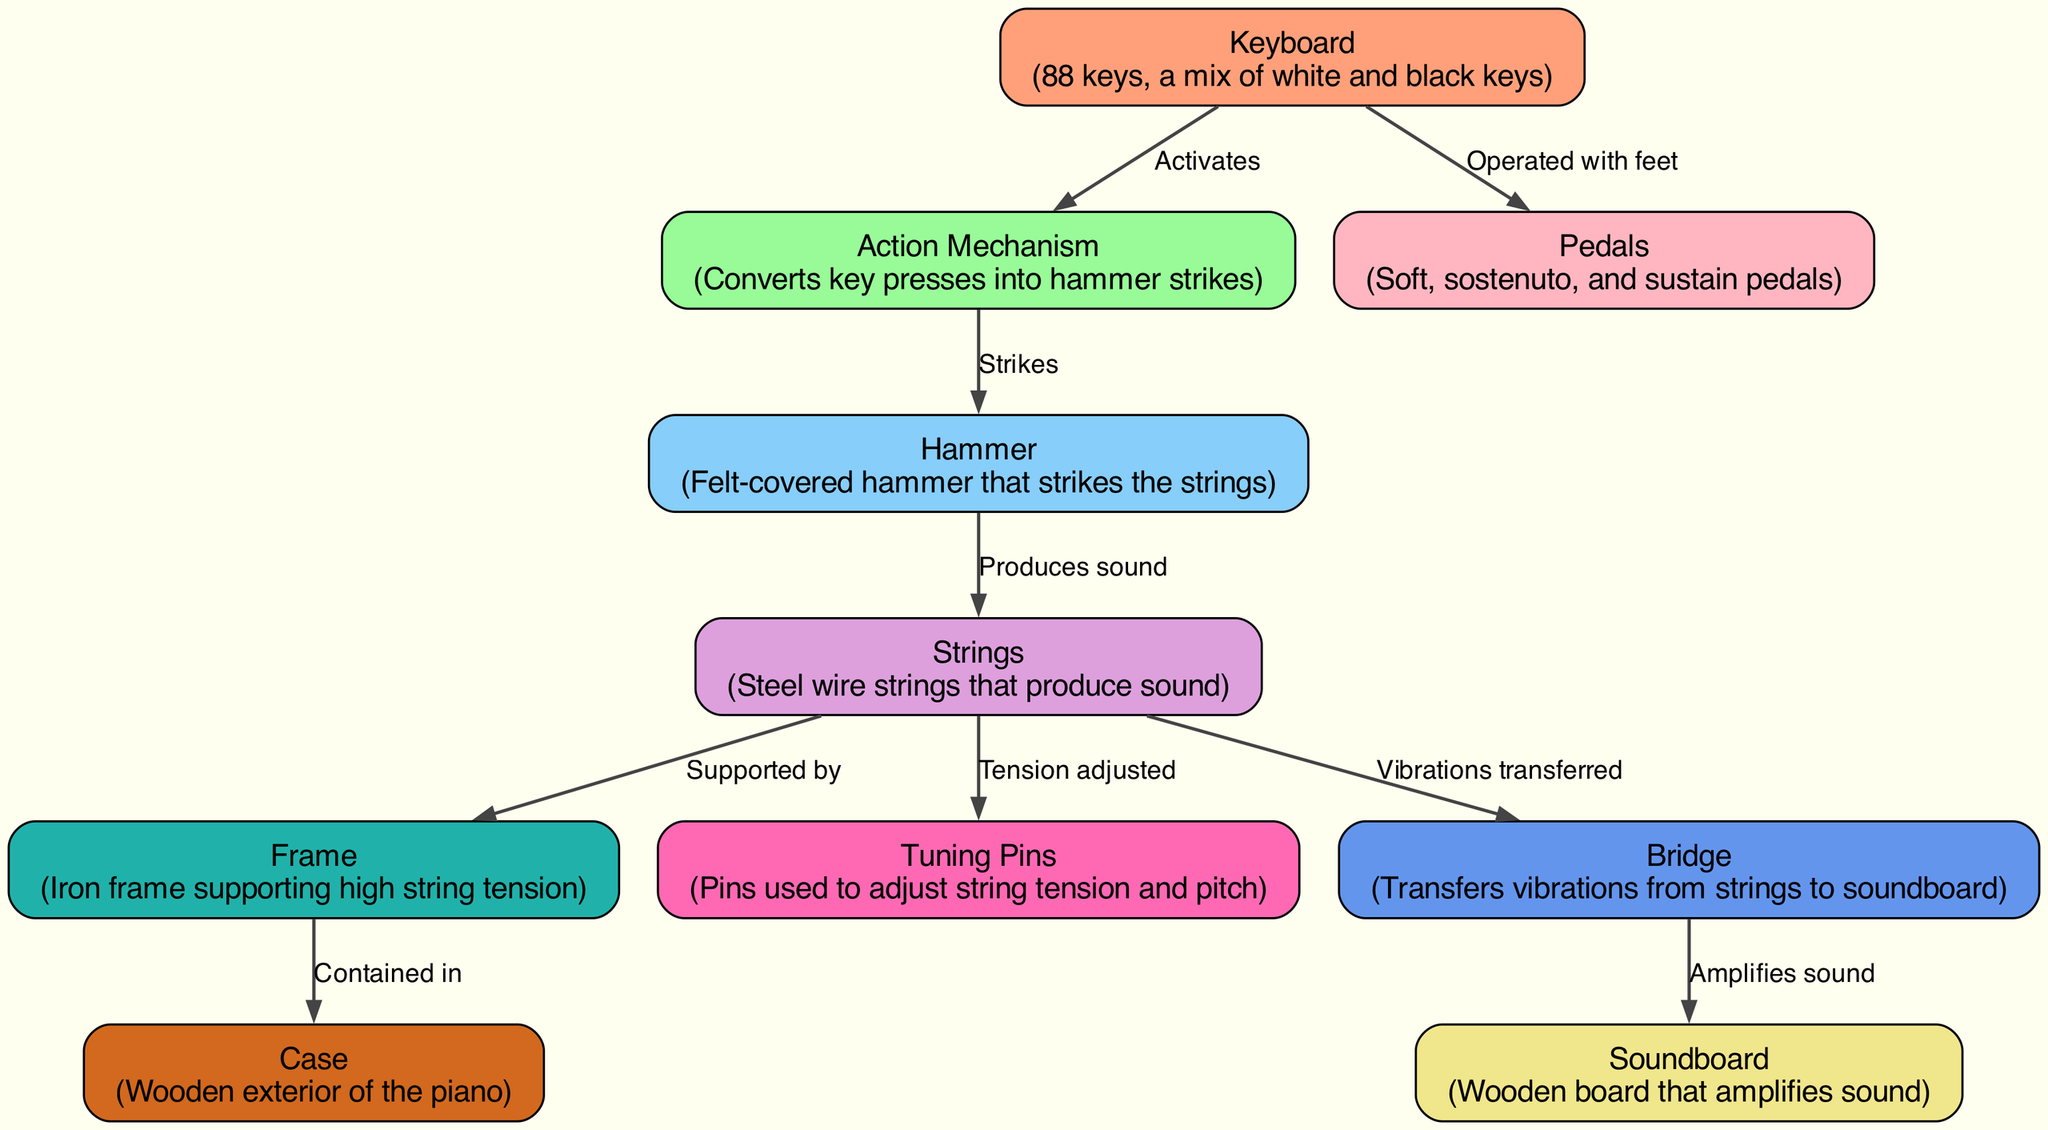What is the total number of nodes in the diagram? The diagram displays the parts of a grand piano represented as nodes. By counting the individual nodes listed, we find that there are 10 nodes in total.
Answer: 10 What does the Action Mechanism convert? The Action Mechanism node is connected to the Keyboard and is labeled "Converts key presses into hammer strikes." Thus, it converts key presses.
Answer: key presses Which component strikes the strings? The edge labeled "Strikes" connects the Action Mechanism to the Hammer, indicating that the Hammer is the component that strikes the strings.
Answer: Hammer How many types of pedals are shown in the diagram? The Pedals node describes three types: soft, sostenuto, and sustain pedals. This can be directly obtained by reading the description under the Pedals node.
Answer: three What is the relationship between Strings and Tuning Pins? The arrow from the Strings to the Tuning Pins indicates that Tuning Pins are used to adjust the tension of the strings, directly depicting this relationship.
Answer: Tension adjusted Which part amplifies the sound from the Bridge? The edge labeled "Amplifies sound" connects the Bridge to the Soundboard. This indicates that the Soundboard is responsible for amplifying sound from the Bridge.
Answer: Soundboard What provides support to high string tension? According to the diagram, the Frame is labeled "Supports high string tension," which clearly shows that it is the component responsible for this support.
Answer: Frame What is the role of the Hammer in sound production? The Hammer strikes the strings and is labeled with "Produces sound." This shows that the Hammer is essential in creating the sound by striking the strings.
Answer: Produces sound Where is the Action Mechanism located in relation to the Keyboard? The Action Mechanism is directly connected to the Keyboard with a label indicating it "Activates," showing that the Action Mechanism is dependent on the Keyboard’s operation.
Answer: Directly connected Which component is described as the wooden exterior of the piano? The Case is labeled as the "Wooden exterior of the piano," providing a straightforward identification of this component.
Answer: Case 